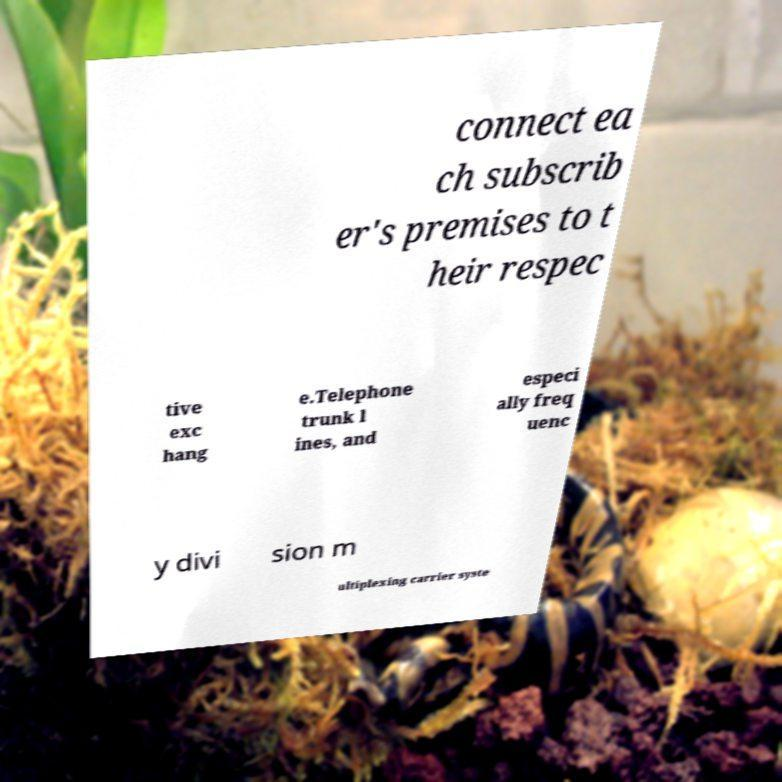I need the written content from this picture converted into text. Can you do that? connect ea ch subscrib er's premises to t heir respec tive exc hang e.Telephone trunk l ines, and especi ally freq uenc y divi sion m ultiplexing carrier syste 